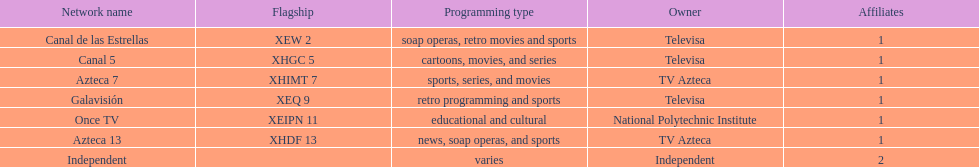Could you parse the entire table as a dict? {'header': ['Network name', 'Flagship', 'Programming type', 'Owner', 'Affiliates'], 'rows': [['Canal de las Estrellas', 'XEW 2', 'soap operas, retro movies and sports', 'Televisa', '1'], ['Canal 5', 'XHGC 5', 'cartoons, movies, and series', 'Televisa', '1'], ['Azteca 7', 'XHIMT 7', 'sports, series, and movies', 'TV Azteca', '1'], ['Galavisión', 'XEQ 9', 'retro programming and sports', 'Televisa', '1'], ['Once TV', 'XEIPN 11', 'educational and cultural', 'National Polytechnic Institute', '1'], ['Azteca 13', 'XHDF 13', 'news, soap operas, and sports', 'TV Azteca', '1'], ['Independent', '', 'varies', 'Independent', '2']]} Who holds ownership of the stations mentioned here? Televisa, Televisa, TV Azteca, Televisa, National Polytechnic Institute, TV Azteca, Independent. Which station is possessed by the national polytechnic institute? Once TV. 